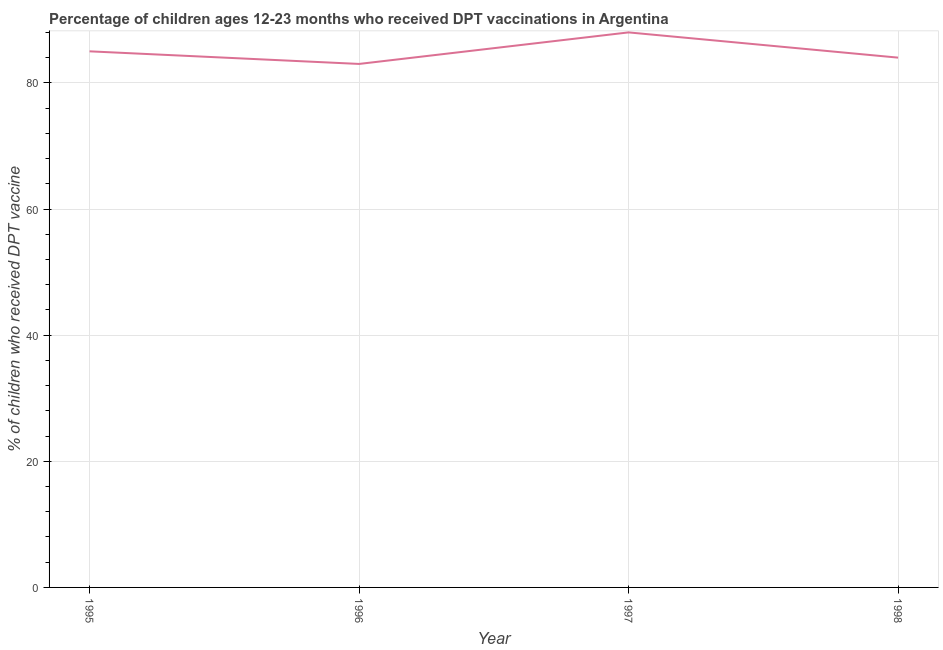What is the percentage of children who received dpt vaccine in 1997?
Make the answer very short. 88. Across all years, what is the maximum percentage of children who received dpt vaccine?
Keep it short and to the point. 88. Across all years, what is the minimum percentage of children who received dpt vaccine?
Give a very brief answer. 83. In which year was the percentage of children who received dpt vaccine maximum?
Your answer should be very brief. 1997. What is the sum of the percentage of children who received dpt vaccine?
Offer a terse response. 340. What is the difference between the percentage of children who received dpt vaccine in 1996 and 1998?
Your response must be concise. -1. What is the median percentage of children who received dpt vaccine?
Your answer should be compact. 84.5. In how many years, is the percentage of children who received dpt vaccine greater than 8 %?
Provide a succinct answer. 4. Do a majority of the years between 1998 and 1997 (inclusive) have percentage of children who received dpt vaccine greater than 52 %?
Your answer should be very brief. No. What is the ratio of the percentage of children who received dpt vaccine in 1997 to that in 1998?
Give a very brief answer. 1.05. What is the difference between the highest and the second highest percentage of children who received dpt vaccine?
Give a very brief answer. 3. Is the sum of the percentage of children who received dpt vaccine in 1997 and 1998 greater than the maximum percentage of children who received dpt vaccine across all years?
Make the answer very short. Yes. What is the difference between the highest and the lowest percentage of children who received dpt vaccine?
Your response must be concise. 5. Does the percentage of children who received dpt vaccine monotonically increase over the years?
Give a very brief answer. No. How many lines are there?
Your answer should be very brief. 1. What is the difference between two consecutive major ticks on the Y-axis?
Your response must be concise. 20. What is the title of the graph?
Give a very brief answer. Percentage of children ages 12-23 months who received DPT vaccinations in Argentina. What is the label or title of the X-axis?
Keep it short and to the point. Year. What is the label or title of the Y-axis?
Offer a very short reply. % of children who received DPT vaccine. What is the % of children who received DPT vaccine in 1995?
Provide a short and direct response. 85. What is the % of children who received DPT vaccine of 1997?
Keep it short and to the point. 88. What is the difference between the % of children who received DPT vaccine in 1995 and 1996?
Provide a succinct answer. 2. What is the difference between the % of children who received DPT vaccine in 1996 and 1997?
Make the answer very short. -5. What is the ratio of the % of children who received DPT vaccine in 1995 to that in 1996?
Offer a very short reply. 1.02. What is the ratio of the % of children who received DPT vaccine in 1995 to that in 1997?
Give a very brief answer. 0.97. What is the ratio of the % of children who received DPT vaccine in 1996 to that in 1997?
Give a very brief answer. 0.94. What is the ratio of the % of children who received DPT vaccine in 1996 to that in 1998?
Give a very brief answer. 0.99. What is the ratio of the % of children who received DPT vaccine in 1997 to that in 1998?
Give a very brief answer. 1.05. 